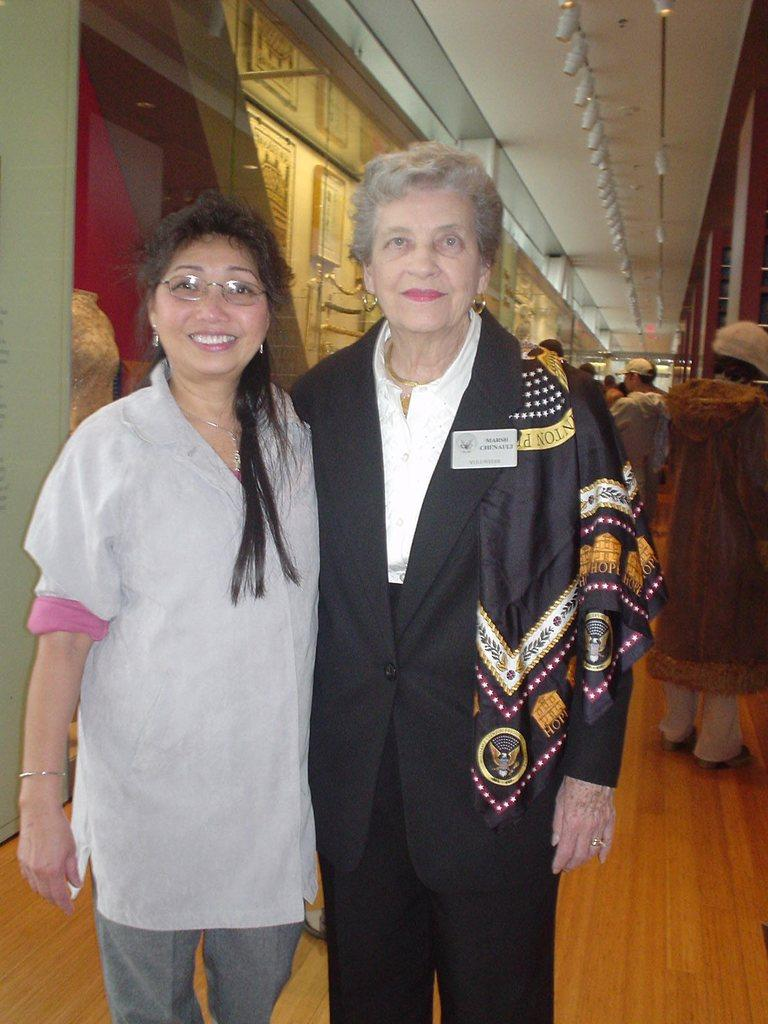How many people are in the image? There are two people in the image. What is the facial expression of the people in the image? The two people are smiling. Can you describe the background of the image? There are people, a floor, a roof, and some objects visible in the background of the image. What type of peace treaty is being signed by the doctor in the image? There is no doctor or peace treaty present in the image. What type of sail can be seen in the image? There is no sail present in the image. 